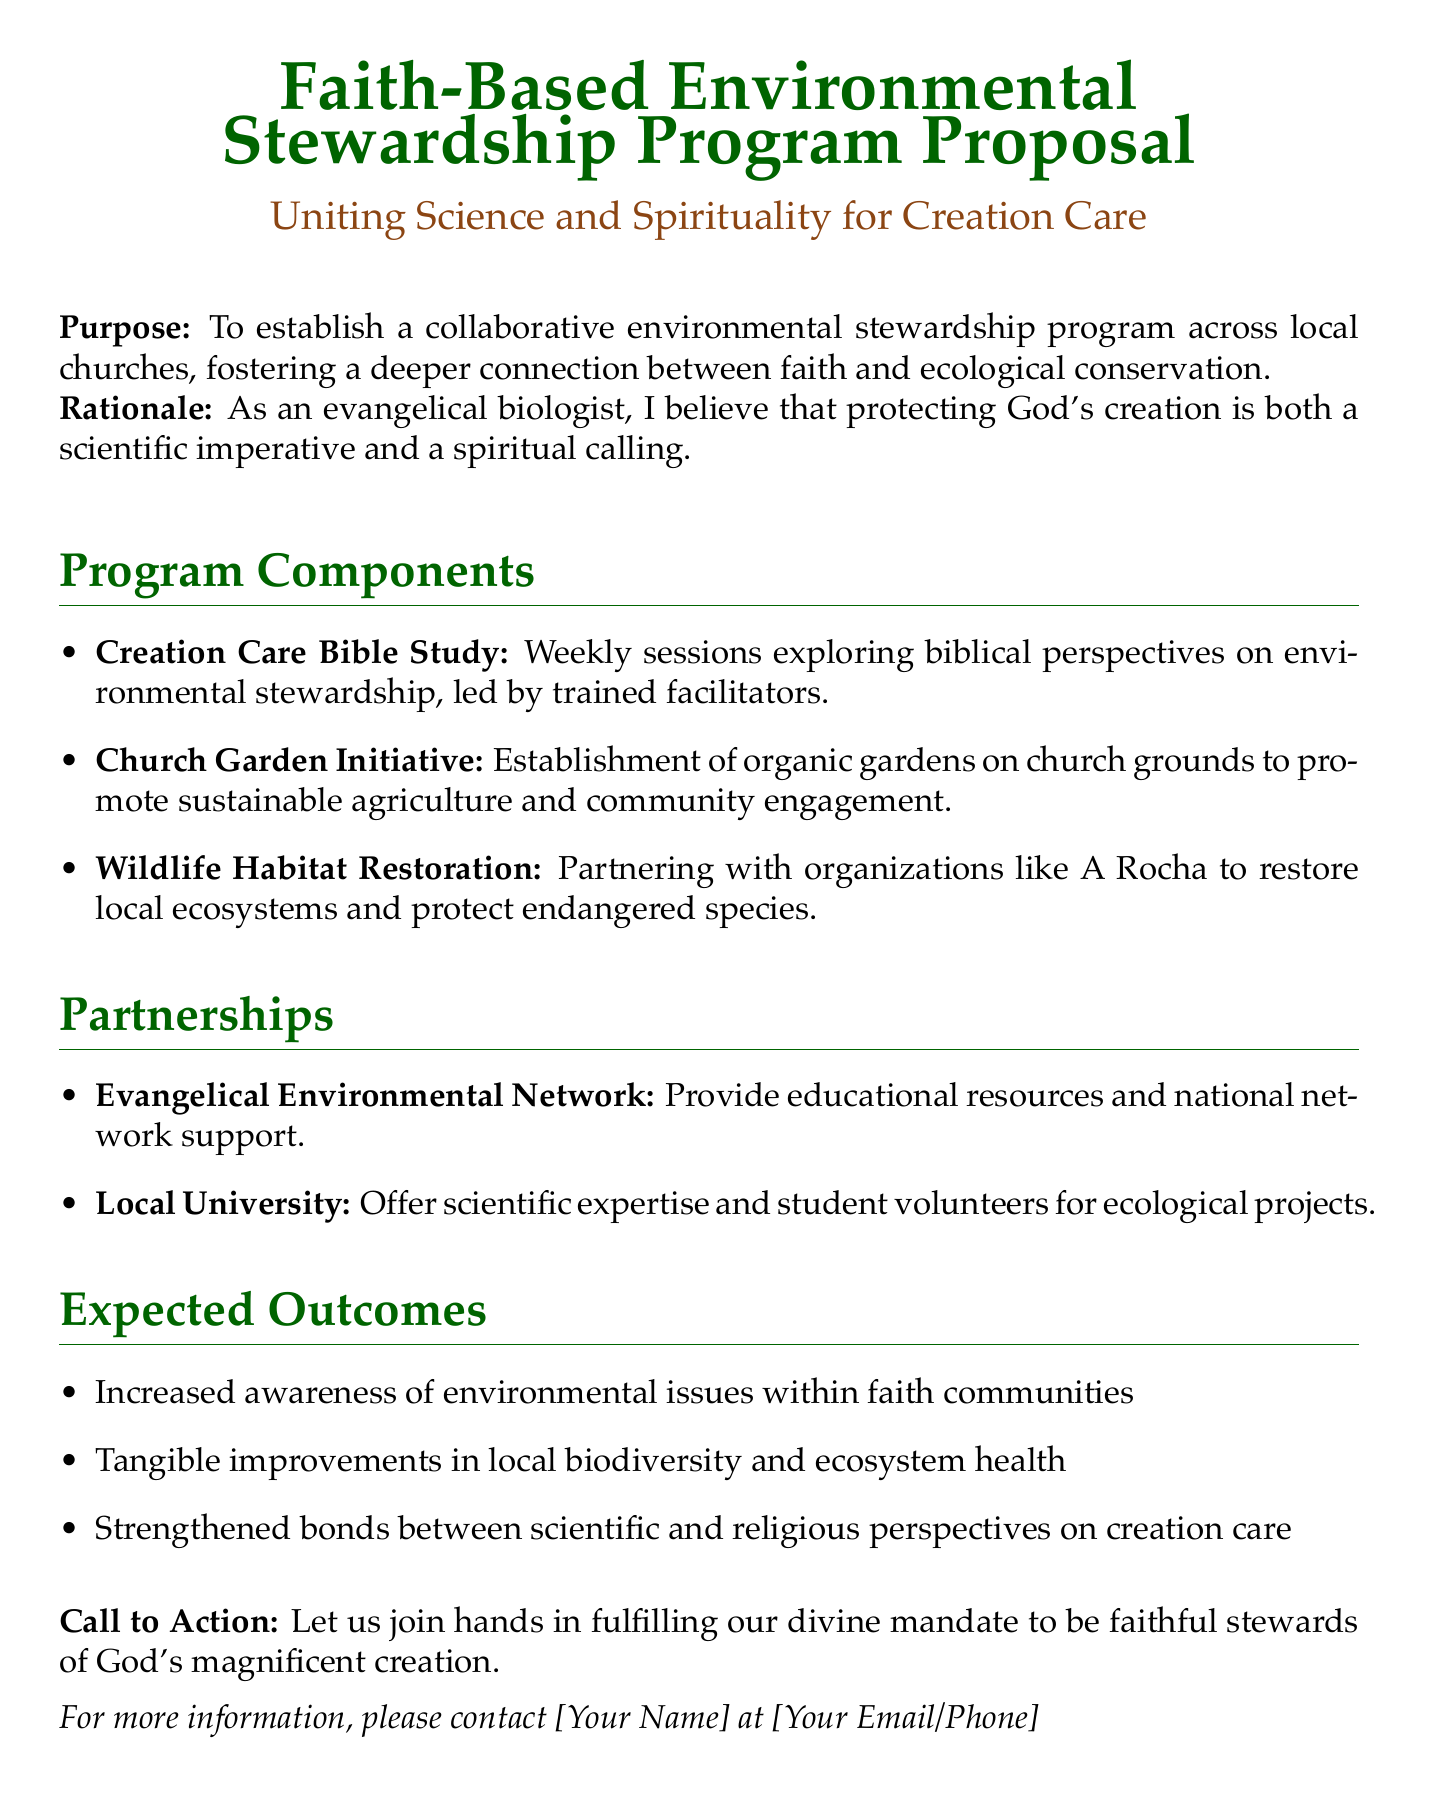What is the purpose of the program? The purpose is to establish a collaborative environmental stewardship program across local churches, fostering a deeper connection between faith and ecological conservation.
Answer: To establish a collaborative environmental stewardship program What organization is mentioned for wildlife habitat restoration? The document mentions partnering with A Rocha for wildlife habitat restoration.
Answer: A Rocha What is one component of the program? The document lists various components, one of which is the Creation Care Bible Study.
Answer: Creation Care Bible Study What are the expected outcomes of the program? The expected outcomes include increased awareness of environmental issues within faith communities.
Answer: Increased awareness of environmental issues How often will the Bible study sessions occur? The document states that the Creation Care Bible Study will have weekly sessions.
Answer: Weekly Which community initiative is highlighted in the proposal? The proposal highlights the Church Garden Initiative as a community engagement effort.
Answer: Church Garden Initiative Who will provide educational resources for the program? The Evangelical Environmental Network will provide educational resources and national network support.
Answer: Evangelical Environmental Network What is the rationale behind the program? The rationale is that protecting God's creation is both a scientific imperative and a spiritual calling.
Answer: Protecting God's creation What type of gardening is proposed in the Church Garden Initiative? The initiative proposes the establishment of organic gardens on church grounds.
Answer: Organic gardens 